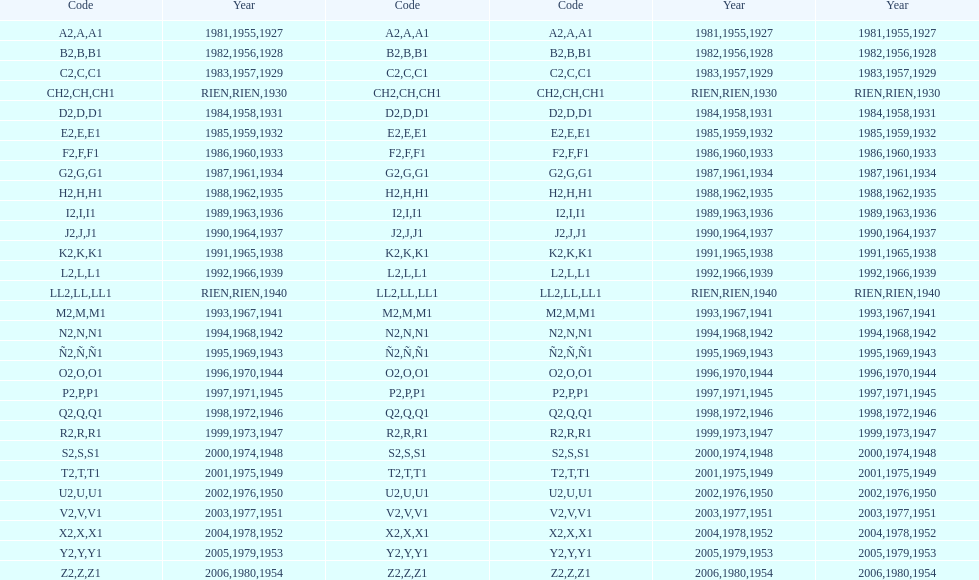Could you parse the entire table? {'header': ['Code', 'Year', 'Code', 'Code', 'Year', 'Year'], 'rows': [['A2', '1981', 'A', 'A1', '1955', '1927'], ['B2', '1982', 'B', 'B1', '1956', '1928'], ['C2', '1983', 'C', 'C1', '1957', '1929'], ['CH2', 'RIEN', 'CH', 'CH1', 'RIEN', '1930'], ['D2', '1984', 'D', 'D1', '1958', '1931'], ['E2', '1985', 'E', 'E1', '1959', '1932'], ['F2', '1986', 'F', 'F1', '1960', '1933'], ['G2', '1987', 'G', 'G1', '1961', '1934'], ['H2', '1988', 'H', 'H1', '1962', '1935'], ['I2', '1989', 'I', 'I1', '1963', '1936'], ['J2', '1990', 'J', 'J1', '1964', '1937'], ['K2', '1991', 'K', 'K1', '1965', '1938'], ['L2', '1992', 'L', 'L1', '1966', '1939'], ['LL2', 'RIEN', 'LL', 'LL1', 'RIEN', '1940'], ['M2', '1993', 'M', 'M1', '1967', '1941'], ['N2', '1994', 'N', 'N1', '1968', '1942'], ['Ñ2', '1995', 'Ñ', 'Ñ1', '1969', '1943'], ['O2', '1996', 'O', 'O1', '1970', '1944'], ['P2', '1997', 'P', 'P1', '1971', '1945'], ['Q2', '1998', 'Q', 'Q1', '1972', '1946'], ['R2', '1999', 'R', 'R1', '1973', '1947'], ['S2', '2000', 'S', 'S1', '1974', '1948'], ['T2', '2001', 'T', 'T1', '1975', '1949'], ['U2', '2002', 'U', 'U1', '1976', '1950'], ['V2', '2003', 'V', 'V1', '1977', '1951'], ['X2', '2004', 'X', 'X1', '1978', '1952'], ['Y2', '2005', 'Y', 'Y1', '1979', '1953'], ['Z2', '2006', 'Z', 'Z1', '1980', '1954']]} Is the e code less than 1950? Yes. 